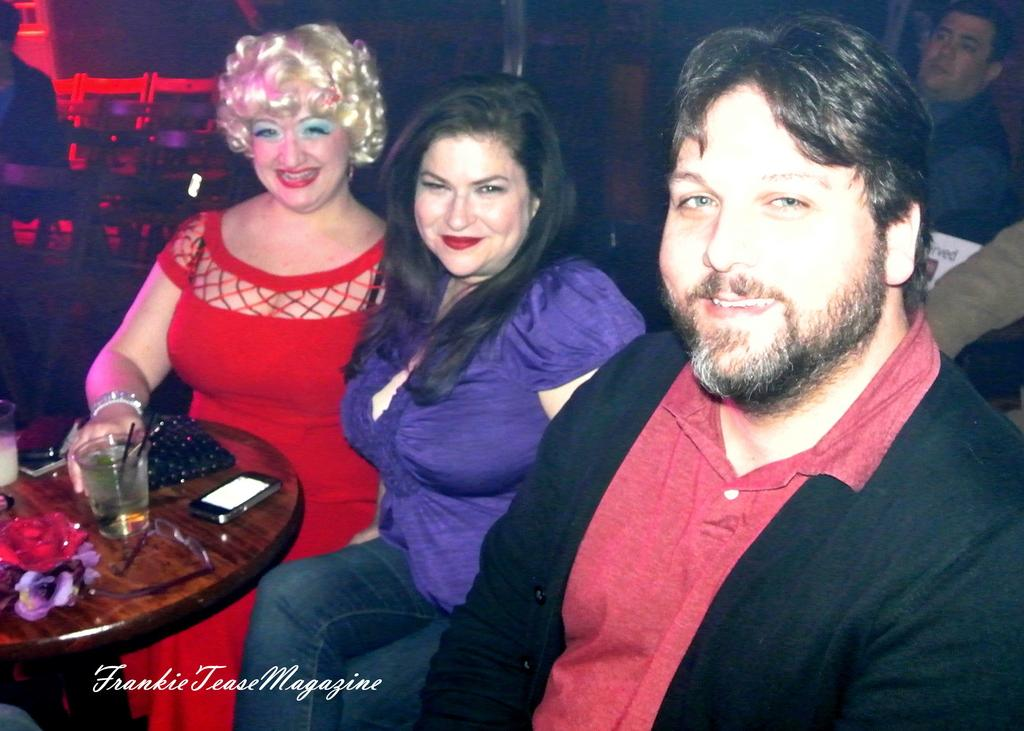How many people are sitting in the image? There are two ladies and one man sitting in the image. What can be seen on the table in the image? There are additional items placed on a table in the image. What object is used for communication in the image? There is a mobile phone in the image. What item might be used for holding or organizing personal belongings? There is a wallet in the image. What type of animals can be seen at the zoo in the image? There is no zoo or animals present in the image. 